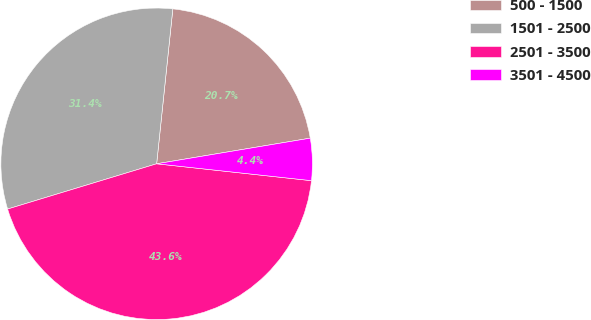<chart> <loc_0><loc_0><loc_500><loc_500><pie_chart><fcel>500 - 1500<fcel>1501 - 2500<fcel>2501 - 3500<fcel>3501 - 4500<nl><fcel>20.71%<fcel>31.35%<fcel>43.58%<fcel>4.36%<nl></chart> 